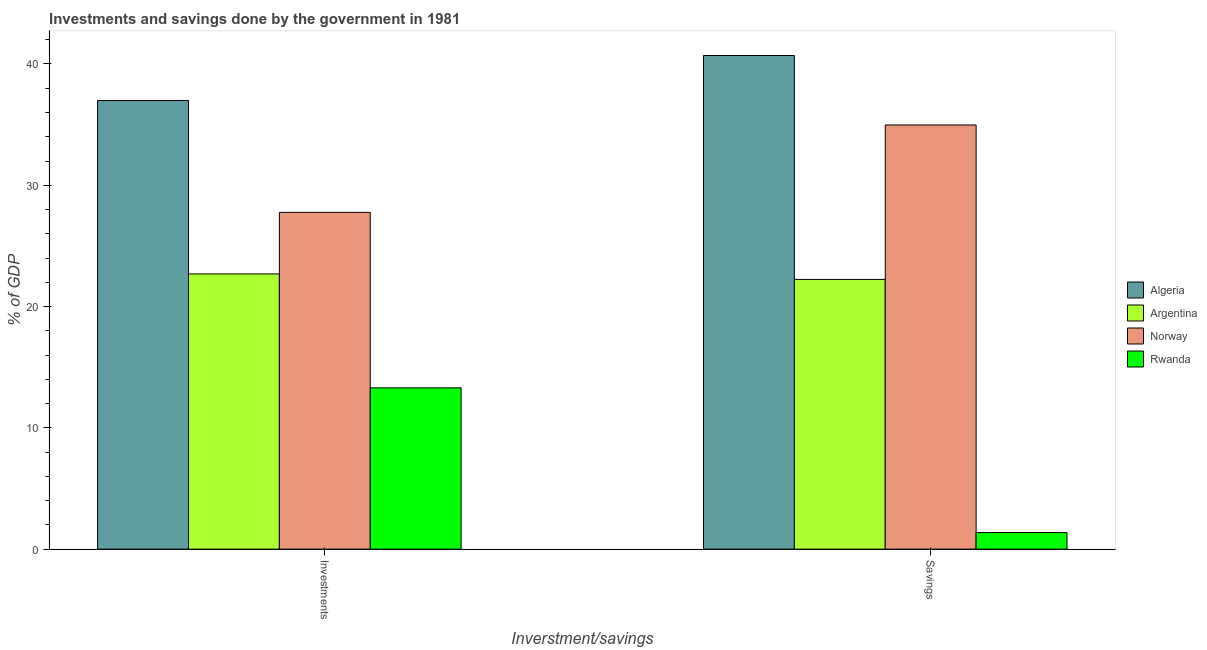How many different coloured bars are there?
Give a very brief answer. 4. Are the number of bars per tick equal to the number of legend labels?
Make the answer very short. Yes. How many bars are there on the 2nd tick from the left?
Give a very brief answer. 4. What is the label of the 1st group of bars from the left?
Your response must be concise. Investments. What is the savings of government in Algeria?
Offer a very short reply. 40.7. Across all countries, what is the maximum investments of government?
Ensure brevity in your answer.  36.99. Across all countries, what is the minimum savings of government?
Make the answer very short. 1.37. In which country was the investments of government maximum?
Your answer should be compact. Algeria. In which country was the savings of government minimum?
Ensure brevity in your answer.  Rwanda. What is the total investments of government in the graph?
Provide a short and direct response. 100.75. What is the difference between the savings of government in Norway and that in Argentina?
Give a very brief answer. 12.73. What is the difference between the savings of government in Argentina and the investments of government in Rwanda?
Offer a terse response. 8.94. What is the average savings of government per country?
Give a very brief answer. 24.82. What is the difference between the savings of government and investments of government in Argentina?
Your answer should be compact. -0.45. What is the ratio of the investments of government in Argentina to that in Algeria?
Provide a succinct answer. 0.61. Is the savings of government in Rwanda less than that in Argentina?
Provide a short and direct response. Yes. In how many countries, is the savings of government greater than the average savings of government taken over all countries?
Your answer should be compact. 2. What does the 1st bar from the left in Investments represents?
Offer a terse response. Algeria. What does the 4th bar from the right in Savings represents?
Your answer should be very brief. Algeria. What is the difference between two consecutive major ticks on the Y-axis?
Offer a terse response. 10. Does the graph contain grids?
Ensure brevity in your answer.  No. How many legend labels are there?
Make the answer very short. 4. What is the title of the graph?
Give a very brief answer. Investments and savings done by the government in 1981. Does "Belarus" appear as one of the legend labels in the graph?
Your answer should be very brief. No. What is the label or title of the X-axis?
Offer a very short reply. Inverstment/savings. What is the label or title of the Y-axis?
Offer a terse response. % of GDP. What is the % of GDP in Algeria in Investments?
Your answer should be very brief. 36.99. What is the % of GDP of Argentina in Investments?
Offer a very short reply. 22.69. What is the % of GDP of Norway in Investments?
Keep it short and to the point. 27.77. What is the % of GDP of Rwanda in Investments?
Provide a succinct answer. 13.3. What is the % of GDP in Algeria in Savings?
Your answer should be very brief. 40.7. What is the % of GDP of Argentina in Savings?
Your response must be concise. 22.24. What is the % of GDP in Norway in Savings?
Ensure brevity in your answer.  34.97. What is the % of GDP in Rwanda in Savings?
Provide a short and direct response. 1.37. Across all Inverstment/savings, what is the maximum % of GDP of Algeria?
Give a very brief answer. 40.7. Across all Inverstment/savings, what is the maximum % of GDP in Argentina?
Offer a terse response. 22.69. Across all Inverstment/savings, what is the maximum % of GDP in Norway?
Your answer should be very brief. 34.97. Across all Inverstment/savings, what is the maximum % of GDP in Rwanda?
Make the answer very short. 13.3. Across all Inverstment/savings, what is the minimum % of GDP of Algeria?
Your answer should be compact. 36.99. Across all Inverstment/savings, what is the minimum % of GDP of Argentina?
Offer a very short reply. 22.24. Across all Inverstment/savings, what is the minimum % of GDP of Norway?
Give a very brief answer. 27.77. Across all Inverstment/savings, what is the minimum % of GDP in Rwanda?
Your response must be concise. 1.37. What is the total % of GDP in Algeria in the graph?
Your answer should be compact. 77.69. What is the total % of GDP of Argentina in the graph?
Ensure brevity in your answer.  44.93. What is the total % of GDP of Norway in the graph?
Offer a very short reply. 62.74. What is the total % of GDP in Rwanda in the graph?
Offer a terse response. 14.67. What is the difference between the % of GDP in Algeria in Investments and that in Savings?
Provide a short and direct response. -3.71. What is the difference between the % of GDP of Argentina in Investments and that in Savings?
Offer a terse response. 0.45. What is the difference between the % of GDP in Norway in Investments and that in Savings?
Provide a short and direct response. -7.2. What is the difference between the % of GDP in Rwanda in Investments and that in Savings?
Make the answer very short. 11.93. What is the difference between the % of GDP in Algeria in Investments and the % of GDP in Argentina in Savings?
Give a very brief answer. 14.75. What is the difference between the % of GDP in Algeria in Investments and the % of GDP in Norway in Savings?
Provide a succinct answer. 2.02. What is the difference between the % of GDP of Algeria in Investments and the % of GDP of Rwanda in Savings?
Your answer should be very brief. 35.62. What is the difference between the % of GDP of Argentina in Investments and the % of GDP of Norway in Savings?
Your answer should be very brief. -12.28. What is the difference between the % of GDP of Argentina in Investments and the % of GDP of Rwanda in Savings?
Offer a terse response. 21.32. What is the difference between the % of GDP in Norway in Investments and the % of GDP in Rwanda in Savings?
Your response must be concise. 26.4. What is the average % of GDP of Algeria per Inverstment/savings?
Provide a short and direct response. 38.85. What is the average % of GDP of Argentina per Inverstment/savings?
Ensure brevity in your answer.  22.47. What is the average % of GDP of Norway per Inverstment/savings?
Your answer should be very brief. 31.37. What is the average % of GDP of Rwanda per Inverstment/savings?
Offer a terse response. 7.33. What is the difference between the % of GDP in Algeria and % of GDP in Argentina in Investments?
Provide a short and direct response. 14.3. What is the difference between the % of GDP of Algeria and % of GDP of Norway in Investments?
Your answer should be compact. 9.22. What is the difference between the % of GDP in Algeria and % of GDP in Rwanda in Investments?
Provide a short and direct response. 23.69. What is the difference between the % of GDP in Argentina and % of GDP in Norway in Investments?
Offer a very short reply. -5.08. What is the difference between the % of GDP of Argentina and % of GDP of Rwanda in Investments?
Make the answer very short. 9.39. What is the difference between the % of GDP in Norway and % of GDP in Rwanda in Investments?
Your answer should be compact. 14.47. What is the difference between the % of GDP in Algeria and % of GDP in Argentina in Savings?
Offer a terse response. 18.46. What is the difference between the % of GDP of Algeria and % of GDP of Norway in Savings?
Keep it short and to the point. 5.73. What is the difference between the % of GDP in Algeria and % of GDP in Rwanda in Savings?
Give a very brief answer. 39.33. What is the difference between the % of GDP in Argentina and % of GDP in Norway in Savings?
Keep it short and to the point. -12.73. What is the difference between the % of GDP of Argentina and % of GDP of Rwanda in Savings?
Your answer should be compact. 20.87. What is the difference between the % of GDP in Norway and % of GDP in Rwanda in Savings?
Make the answer very short. 33.6. What is the ratio of the % of GDP in Algeria in Investments to that in Savings?
Keep it short and to the point. 0.91. What is the ratio of the % of GDP of Argentina in Investments to that in Savings?
Ensure brevity in your answer.  1.02. What is the ratio of the % of GDP of Norway in Investments to that in Savings?
Keep it short and to the point. 0.79. What is the ratio of the % of GDP in Rwanda in Investments to that in Savings?
Give a very brief answer. 9.71. What is the difference between the highest and the second highest % of GDP of Algeria?
Offer a terse response. 3.71. What is the difference between the highest and the second highest % of GDP of Argentina?
Make the answer very short. 0.45. What is the difference between the highest and the second highest % of GDP of Norway?
Your answer should be very brief. 7.2. What is the difference between the highest and the second highest % of GDP of Rwanda?
Keep it short and to the point. 11.93. What is the difference between the highest and the lowest % of GDP in Algeria?
Keep it short and to the point. 3.71. What is the difference between the highest and the lowest % of GDP of Argentina?
Keep it short and to the point. 0.45. What is the difference between the highest and the lowest % of GDP in Norway?
Give a very brief answer. 7.2. What is the difference between the highest and the lowest % of GDP of Rwanda?
Make the answer very short. 11.93. 